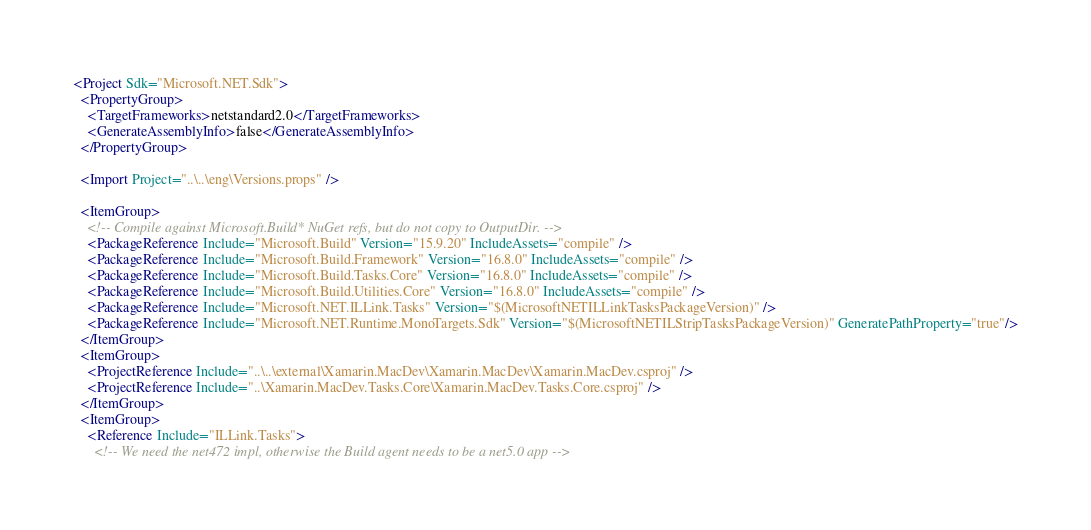<code> <loc_0><loc_0><loc_500><loc_500><_XML_><Project Sdk="Microsoft.NET.Sdk">
  <PropertyGroup>
    <TargetFrameworks>netstandard2.0</TargetFrameworks>
    <GenerateAssemblyInfo>false</GenerateAssemblyInfo>
  </PropertyGroup>

  <Import Project="..\..\eng\Versions.props" />

  <ItemGroup>
    <!-- Compile against Microsoft.Build* NuGet refs, but do not copy to OutputDir. -->
    <PackageReference Include="Microsoft.Build" Version="15.9.20" IncludeAssets="compile" />
    <PackageReference Include="Microsoft.Build.Framework" Version="16.8.0" IncludeAssets="compile" />
    <PackageReference Include="Microsoft.Build.Tasks.Core" Version="16.8.0" IncludeAssets="compile" />
    <PackageReference Include="Microsoft.Build.Utilities.Core" Version="16.8.0" IncludeAssets="compile" />
    <PackageReference Include="Microsoft.NET.ILLink.Tasks" Version="$(MicrosoftNETILLinkTasksPackageVersion)" />
    <PackageReference Include="Microsoft.NET.Runtime.MonoTargets.Sdk" Version="$(MicrosoftNETILStripTasksPackageVersion)" GeneratePathProperty="true"/>
  </ItemGroup>
  <ItemGroup>
    <ProjectReference Include="..\..\external\Xamarin.MacDev\Xamarin.MacDev\Xamarin.MacDev.csproj" />
    <ProjectReference Include="..\Xamarin.MacDev.Tasks.Core\Xamarin.MacDev.Tasks.Core.csproj" />
  </ItemGroup>
  <ItemGroup>
    <Reference Include="ILLink.Tasks">
      <!-- We need the net472 impl, otherwise the Build agent needs to be a net5.0 app --></code> 